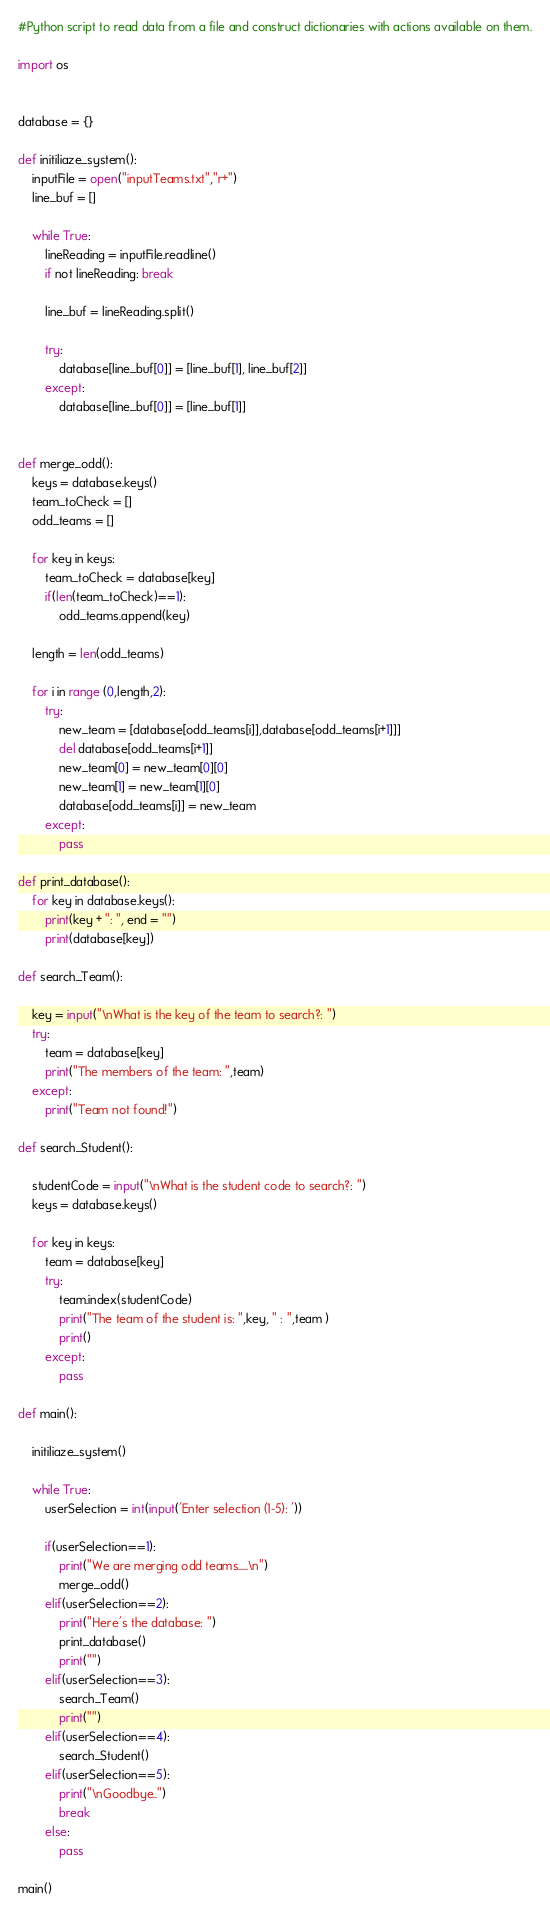Convert code to text. <code><loc_0><loc_0><loc_500><loc_500><_Python_>#Python script to read data from a file and construct dictionaries with actions available on them.

import os


database = {}

def initiliaze_system():
    inputFile = open("inputTeams.txt","r+")
    line_buf = []

    while True:
        lineReading = inputFile.readline()
        if not lineReading: break
        
        line_buf = lineReading.split()
        
        try:
            database[line_buf[0]] = [line_buf[1], line_buf[2]]
        except:
            database[line_buf[0]] = [line_buf[1]]
    

def merge_odd():
    keys = database.keys()
    team_toCheck = []
    odd_teams = []

    for key in keys:
        team_toCheck = database[key]
        if(len(team_toCheck)==1):
            odd_teams.append(key)

    length = len(odd_teams)

    for i in range (0,length,2):
        try:
            new_team = [database[odd_teams[i]],database[odd_teams[i+1]]]
            del database[odd_teams[i+1]]
            new_team[0] = new_team[0][0]
            new_team[1] = new_team[1][0]
            database[odd_teams[i]] = new_team
        except:
            pass

def print_database():
    for key in database.keys():
        print(key + ": ", end = "")
        print(database[key])

def search_Team():
    
    key = input("\nWhat is the key of the team to search?: ")
    try:
        team = database[key]
        print("The members of the team: ",team)
    except:
        print("Team not found!")

def search_Student():

    studentCode = input("\nWhat is the student code to search?: ")
    keys = database.keys()

    for key in keys:
        team = database[key]
        try:
            team.index(studentCode)
            print("The team of the student is: ",key, " : ",team )
            print()
        except:
            pass

def main():

    initiliaze_system()

    while True:
        userSelection = int(input('Enter selection (1-5): '))

        if(userSelection==1):
            print("We are merging odd teams.....\n")
            merge_odd()
        elif(userSelection==2):
            print("Here's the database: ")
            print_database()
            print("")
        elif(userSelection==3):
            search_Team()
            print("")
        elif(userSelection==4):
            search_Student()
        elif(userSelection==5):
            print("\nGoodbye..")
            break
        else:
            pass

main()</code> 